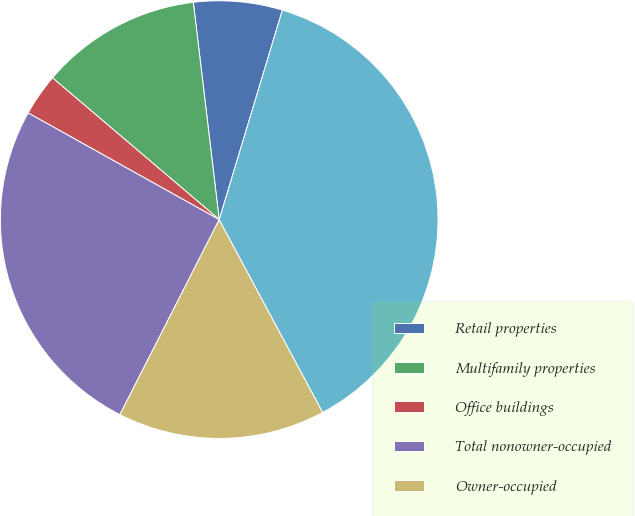Convert chart to OTSL. <chart><loc_0><loc_0><loc_500><loc_500><pie_chart><fcel>Retail properties<fcel>Multifamily properties<fcel>Office buildings<fcel>Total nonowner-occupied<fcel>Owner-occupied<fcel>Total<nl><fcel>6.55%<fcel>11.9%<fcel>3.11%<fcel>25.61%<fcel>15.34%<fcel>37.5%<nl></chart> 